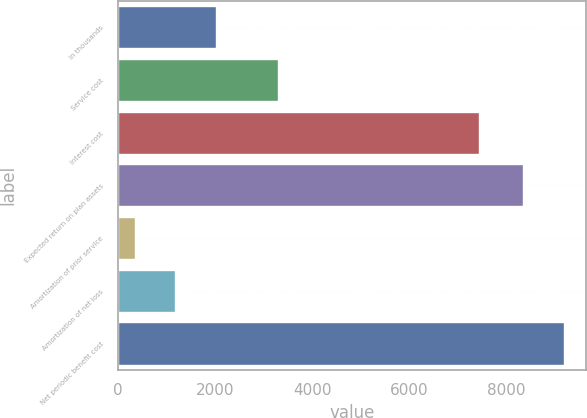Convert chart. <chart><loc_0><loc_0><loc_500><loc_500><bar_chart><fcel>In thousands<fcel>Service cost<fcel>Interest cost<fcel>Expected return on plan assets<fcel>Amortization of prior service<fcel>Amortization of net loss<fcel>Net periodic benefit cost<nl><fcel>2015.6<fcel>3299<fcel>7438<fcel>8344<fcel>351<fcel>1183.3<fcel>9176.3<nl></chart> 